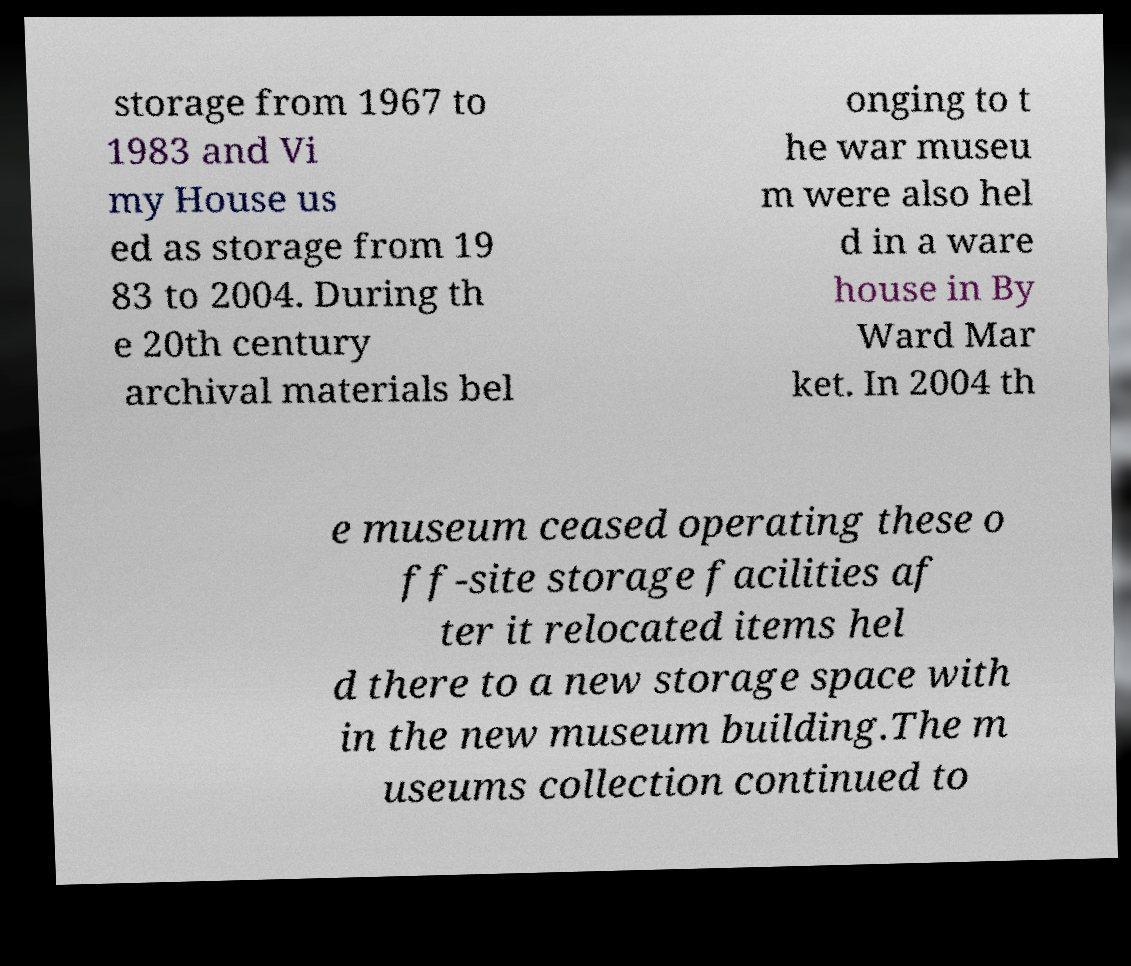Could you assist in decoding the text presented in this image and type it out clearly? storage from 1967 to 1983 and Vi my House us ed as storage from 19 83 to 2004. During th e 20th century archival materials bel onging to t he war museu m were also hel d in a ware house in By Ward Mar ket. In 2004 th e museum ceased operating these o ff-site storage facilities af ter it relocated items hel d there to a new storage space with in the new museum building.The m useums collection continued to 